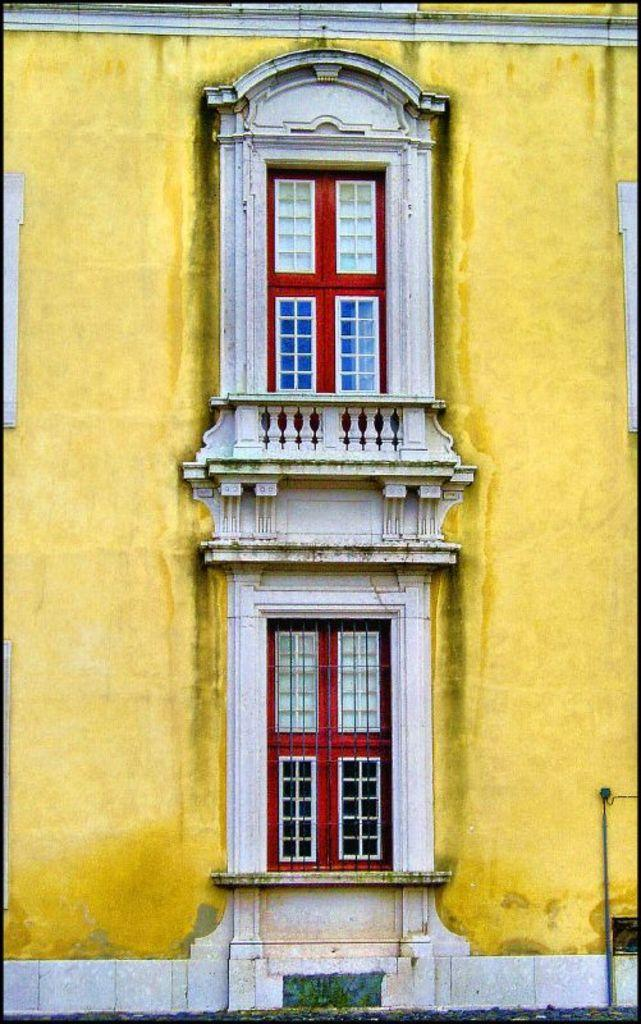What is the main subject of the picture? The main subject of the picture is a building. What can be observed about the building's appearance? The building has a yellow-colored wall. Are there any specific features on the building? Yes, there are windows on the building. What is the color of the windows? The windows are red in color. Can you describe the structure of the bite mark on the building? There is no bite mark visible on the building in the image. 